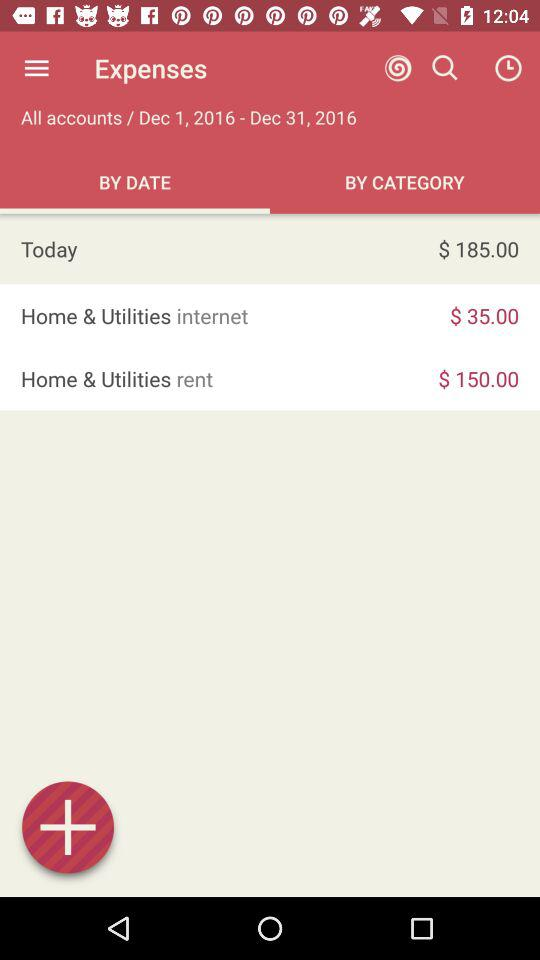What is the date range? The date range is from December 1, 2016 to December 31, 2016. 